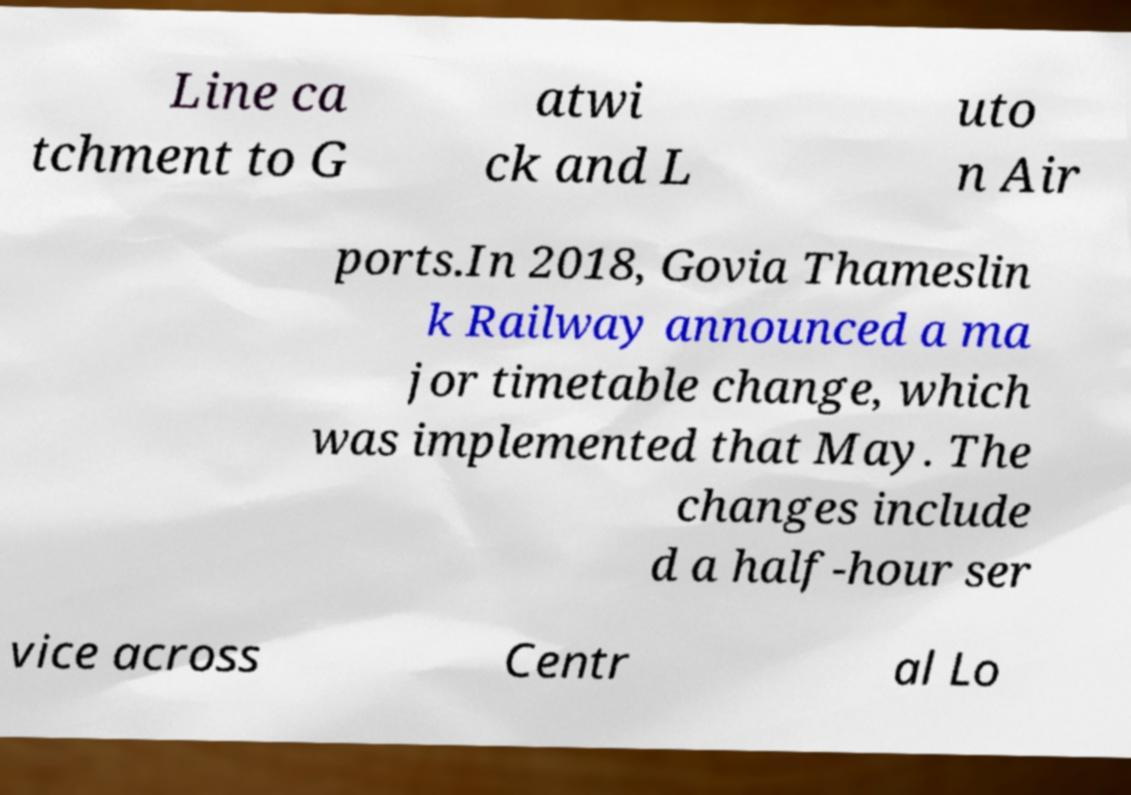There's text embedded in this image that I need extracted. Can you transcribe it verbatim? Line ca tchment to G atwi ck and L uto n Air ports.In 2018, Govia Thameslin k Railway announced a ma jor timetable change, which was implemented that May. The changes include d a half-hour ser vice across Centr al Lo 